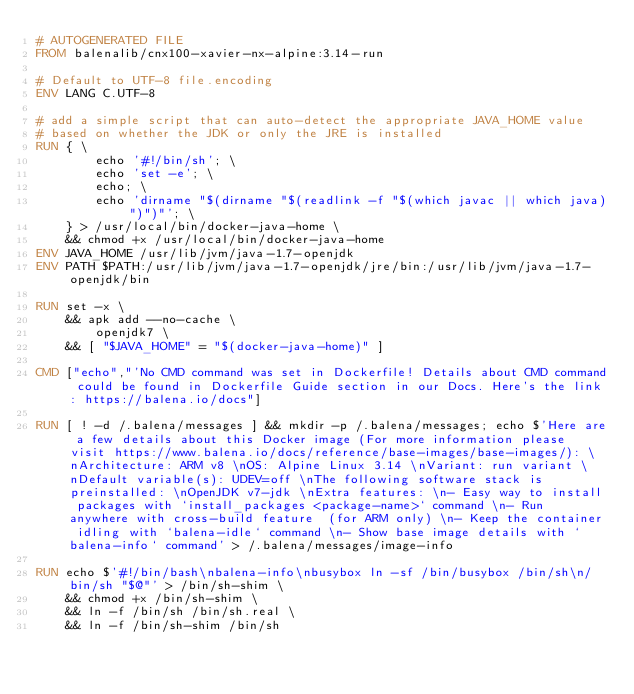<code> <loc_0><loc_0><loc_500><loc_500><_Dockerfile_># AUTOGENERATED FILE
FROM balenalib/cnx100-xavier-nx-alpine:3.14-run

# Default to UTF-8 file.encoding
ENV LANG C.UTF-8

# add a simple script that can auto-detect the appropriate JAVA_HOME value
# based on whether the JDK or only the JRE is installed
RUN { \
		echo '#!/bin/sh'; \
		echo 'set -e'; \
		echo; \
		echo 'dirname "$(dirname "$(readlink -f "$(which javac || which java)")")"'; \
	} > /usr/local/bin/docker-java-home \
	&& chmod +x /usr/local/bin/docker-java-home
ENV JAVA_HOME /usr/lib/jvm/java-1.7-openjdk
ENV PATH $PATH:/usr/lib/jvm/java-1.7-openjdk/jre/bin:/usr/lib/jvm/java-1.7-openjdk/bin

RUN set -x \
	&& apk add --no-cache \
		openjdk7 \
	&& [ "$JAVA_HOME" = "$(docker-java-home)" ]

CMD ["echo","'No CMD command was set in Dockerfile! Details about CMD command could be found in Dockerfile Guide section in our Docs. Here's the link: https://balena.io/docs"]

RUN [ ! -d /.balena/messages ] && mkdir -p /.balena/messages; echo $'Here are a few details about this Docker image (For more information please visit https://www.balena.io/docs/reference/base-images/base-images/): \nArchitecture: ARM v8 \nOS: Alpine Linux 3.14 \nVariant: run variant \nDefault variable(s): UDEV=off \nThe following software stack is preinstalled: \nOpenJDK v7-jdk \nExtra features: \n- Easy way to install packages with `install_packages <package-name>` command \n- Run anywhere with cross-build feature  (for ARM only) \n- Keep the container idling with `balena-idle` command \n- Show base image details with `balena-info` command' > /.balena/messages/image-info

RUN echo $'#!/bin/bash\nbalena-info\nbusybox ln -sf /bin/busybox /bin/sh\n/bin/sh "$@"' > /bin/sh-shim \
	&& chmod +x /bin/sh-shim \
	&& ln -f /bin/sh /bin/sh.real \
	&& ln -f /bin/sh-shim /bin/sh</code> 